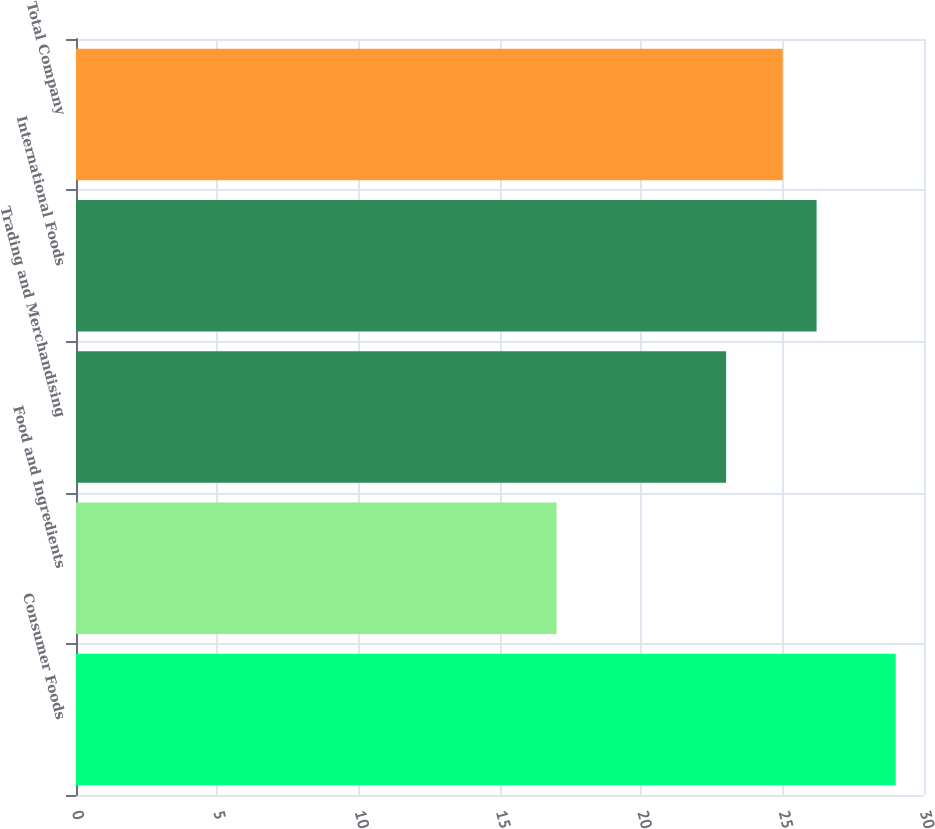<chart> <loc_0><loc_0><loc_500><loc_500><bar_chart><fcel>Consumer Foods<fcel>Food and Ingredients<fcel>Trading and Merchandising<fcel>International Foods<fcel>Total Company<nl><fcel>29<fcel>17<fcel>23<fcel>26.2<fcel>25<nl></chart> 